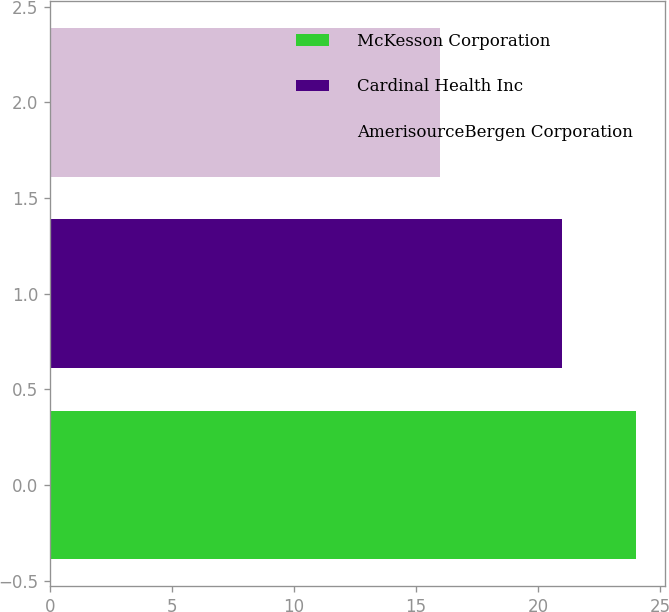Convert chart. <chart><loc_0><loc_0><loc_500><loc_500><bar_chart><fcel>McKesson Corporation<fcel>Cardinal Health Inc<fcel>AmerisourceBergen Corporation<nl><fcel>24<fcel>21<fcel>16<nl></chart> 